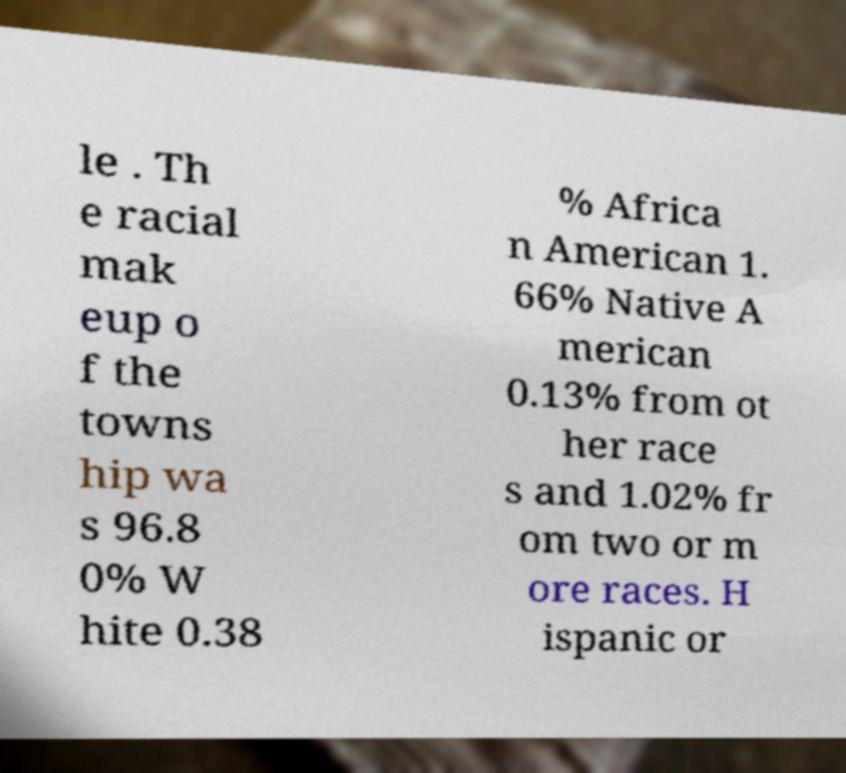What messages or text are displayed in this image? I need them in a readable, typed format. le . Th e racial mak eup o f the towns hip wa s 96.8 0% W hite 0.38 % Africa n American 1. 66% Native A merican 0.13% from ot her race s and 1.02% fr om two or m ore races. H ispanic or 